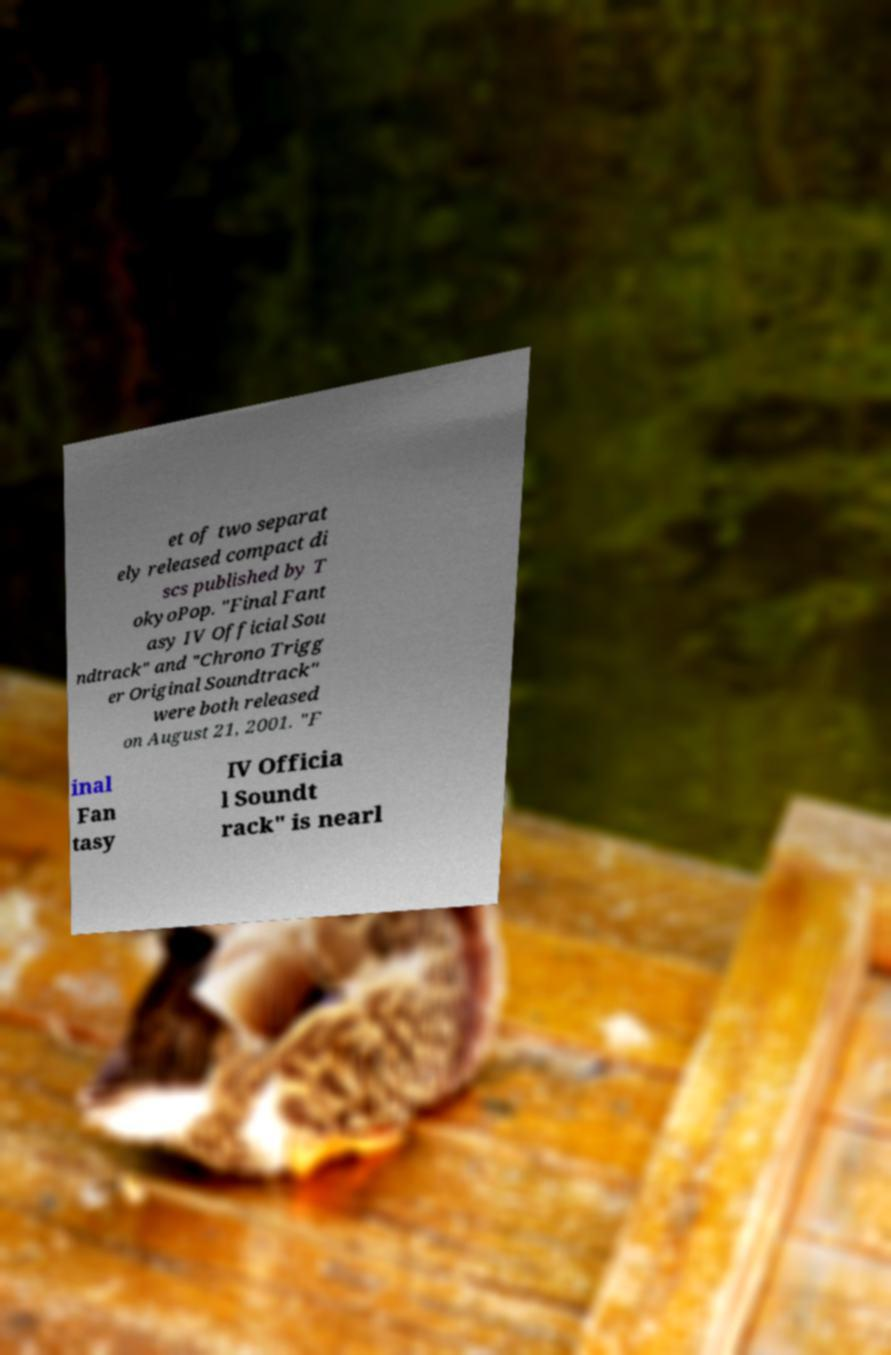For documentation purposes, I need the text within this image transcribed. Could you provide that? et of two separat ely released compact di scs published by T okyoPop. "Final Fant asy IV Official Sou ndtrack" and "Chrono Trigg er Original Soundtrack" were both released on August 21, 2001. "F inal Fan tasy IV Officia l Soundt rack" is nearl 